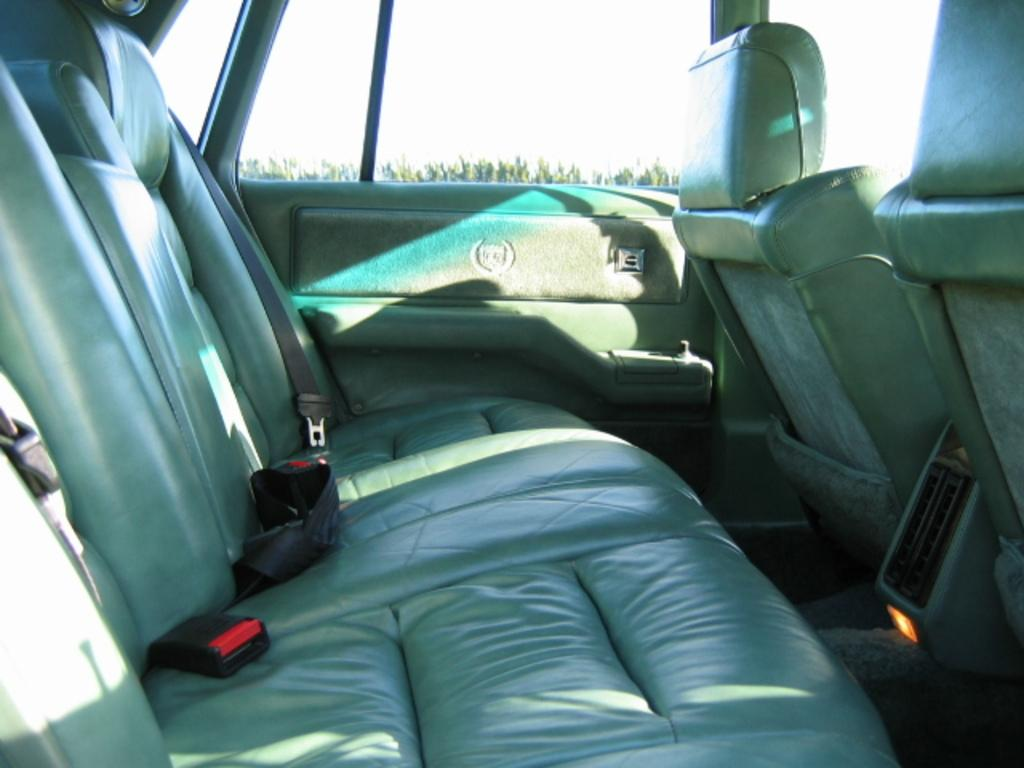What is the location of the person taking the image? The image is taken from inside a car. What can be seen through the car window? Trees and the sky are visible through the car window. Can you determine the time of day based on the image? The image is likely taken during the day, as the sky is visible. What type of measuring tool is being used to determine the distance between the trees in the image? There is no measuring tool visible in the image, and the distance between the trees cannot be determined from the image alone. 